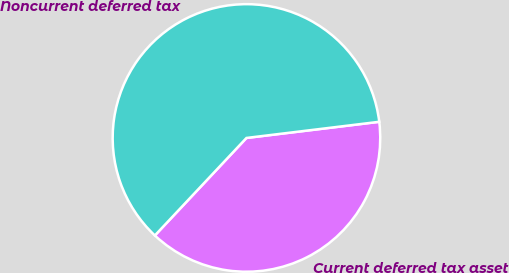<chart> <loc_0><loc_0><loc_500><loc_500><pie_chart><fcel>Current deferred tax asset<fcel>Noncurrent deferred tax<nl><fcel>38.93%<fcel>61.07%<nl></chart> 